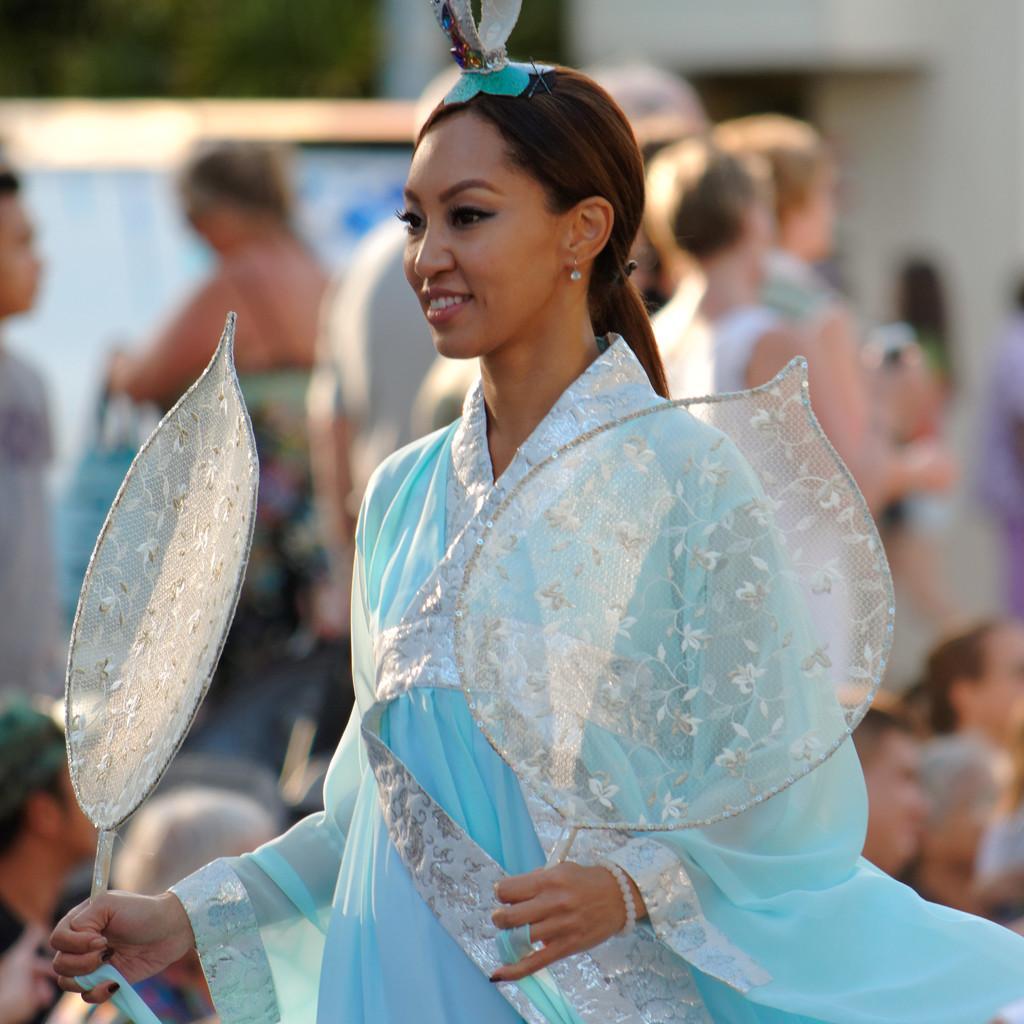Please provide a concise description of this image. This picture is clicked outside. In the foreground there is a woman wearing a blue color dress, holding some objects and seems to be walking. In the background we can see the group of people and a building and some other objects. 